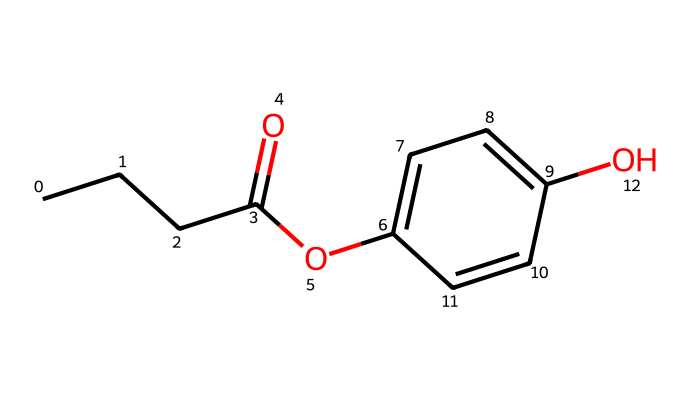What is the molecular formula of propylparaben? To find the molecular formula, we count the number of each type of atom in the chemical structure based on the SMILES representation. The structure has 10 carbon atoms, 12 hydrogen atoms, and 4 oxygen atoms, resulting in the formula C10H12O4.
Answer: C10H12O4 How many hydroxyl (–OH) groups are present in propylparaben? By examining the structure, we can identify the presence of hydroxyl groups. There is one –OH group attached to the aromatic ring part of the molecule, indicating there is one hydroxyl group present.
Answer: 1 What type of functional group is featured in propylparaben? By looking at the structure, we can identify that propylparaben has an ester functional group (–COO–) due to the carbonyl (C=O) and alkoxy (–O) components in the molecule.
Answer: ester Is propylparaben hydrophilic or hydrophobic? The presence of the hydroxyl group suggests a degree of hydrophilicity; however, the long carbon chain contributes to hydrophobic characteristics. The overall balance leans towards hydrophobic due to the larger hydrocarbon part.
Answer: hydrophobic What role does propylparaben play in art supplies? Propylparaben is used as a preservative in art supplies to prevent microbial growth, extending shelf life. This function is essential in products that contain water or organic materials that could spoil.
Answer: preservative How many rings are present in the propylparaben structure? By inspecting the structure, we find that there is one aromatic ring comprised of six carbon atoms, which contributes to the overall properties of propylparaben.
Answer: 1 